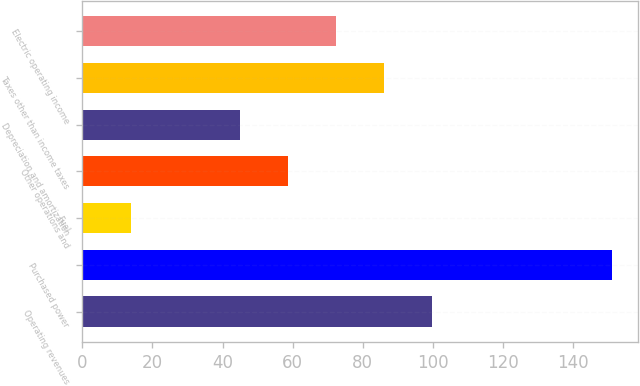Convert chart to OTSL. <chart><loc_0><loc_0><loc_500><loc_500><bar_chart><fcel>Operating revenues<fcel>Purchased power<fcel>Fuel<fcel>Other operations and<fcel>Depreciation and amortization<fcel>Taxes other than income taxes<fcel>Electric operating income<nl><fcel>99.8<fcel>151<fcel>14<fcel>58.7<fcel>45<fcel>86.1<fcel>72.4<nl></chart> 